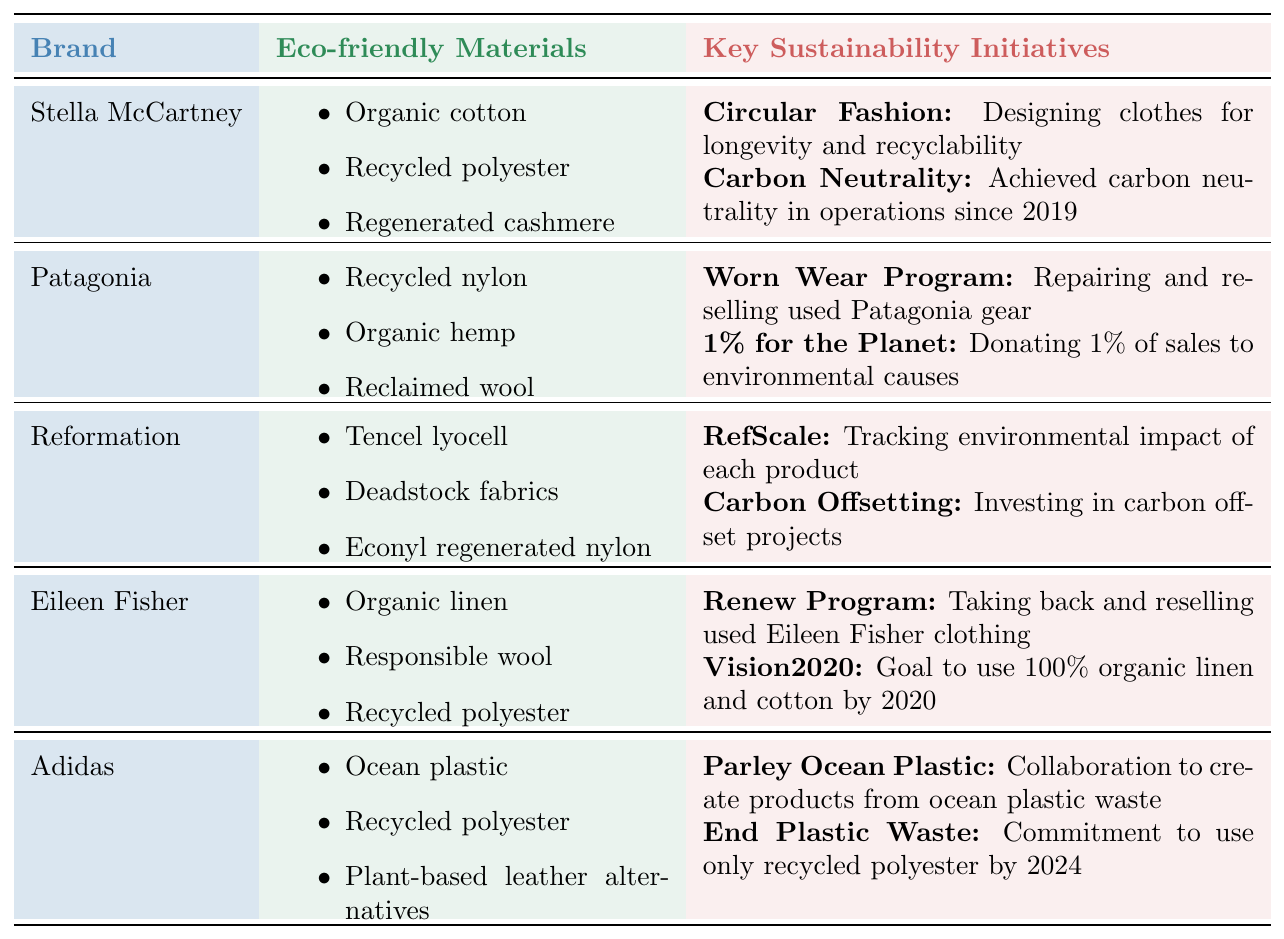What eco-friendly materials does Stella McCartney use? The table lists "Organic cotton," "Recycled polyester," and "Regenerated cashmere" as the eco-friendly materials used by Stella McCartney.
Answer: Organic cotton, Recycled polyester, Regenerated cashmere How many key sustainability initiatives does Patagonia have? The table shows that Patagonia has two key sustainability initiatives: the Worn Wear Program and the 1% for the Planet.
Answer: 2 Does Eileen Fisher focus on organic materials? The table indicates that Eileen Fisher uses "Organic linen" and "Responsible wool," which are organic materials, confirming that the brand focuses on them.
Answer: Yes Which brand has a focus on circular fashion? The table shows that Stella McCartney has an initiative on Circular Fashion, indicating that the brand focuses on designing clothes for longevity and recyclability.
Answer: Stella McCartney What materials are shared between Eileen Fisher and Reformation? Reviewing the table reveals that both brands use "Recycled polyester," making it a common material between them.
Answer: Recycled polyester Is there any brand that donates a percentage of sales to environmental causes? The table lists Patagonia's initiative "1% for the Planet," which specifies that they donate 1% of their sales to environmental causes, confirming that they do so.
Answer: Yes Which brand has set a goal to utilize 100% organic linen and cotton, and what is that goal's deadline? The table states that Eileen Fisher has the initiative "Vision2020," aiming to use 100% organic linen and cotton by the year 2020.
Answer: Eileen Fisher, 2020 How many unique eco-friendly materials are mentioned across all brands? The eco-friendly materials listed are Organic cotton, Recycled polyester, Regenerated cashmere, Recycled nylon, Organic hemp, Reclaimed wool, Tencel lyocell, Deadstock fabrics, Econyl regenerated nylon, Organic linen, Responsible wool, Ocean plastic, and Plant-based leather alternatives, totaling 12 unique materials.
Answer: 12 Which brand has a specific initiative focusing on ocean plastic waste? According to the table, Adidas has the "Parley Ocean Plastic" initiative that collaborates to create products using ocean plastic waste.
Answer: Adidas What is the relationship between Reformation's RefScale initiative and its materials usage? The RefScale initiative, which tracks the environmental impact of each product, relates to their use of eco-friendly materials like Tencel lyocell and Econyl regenerated nylon, emphasizing sustainable material sourcing.
Answer: Material sourcing impacts tracking 